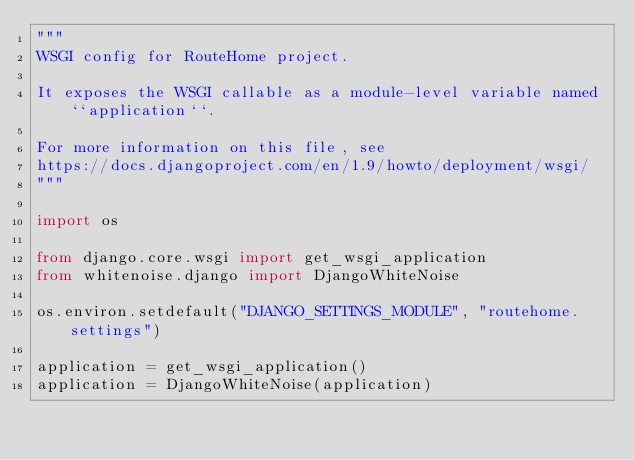Convert code to text. <code><loc_0><loc_0><loc_500><loc_500><_Python_>"""
WSGI config for RouteHome project.

It exposes the WSGI callable as a module-level variable named ``application``.

For more information on this file, see
https://docs.djangoproject.com/en/1.9/howto/deployment/wsgi/
"""

import os

from django.core.wsgi import get_wsgi_application
from whitenoise.django import DjangoWhiteNoise

os.environ.setdefault("DJANGO_SETTINGS_MODULE", "routehome.settings")

application = get_wsgi_application()
application = DjangoWhiteNoise(application)
</code> 